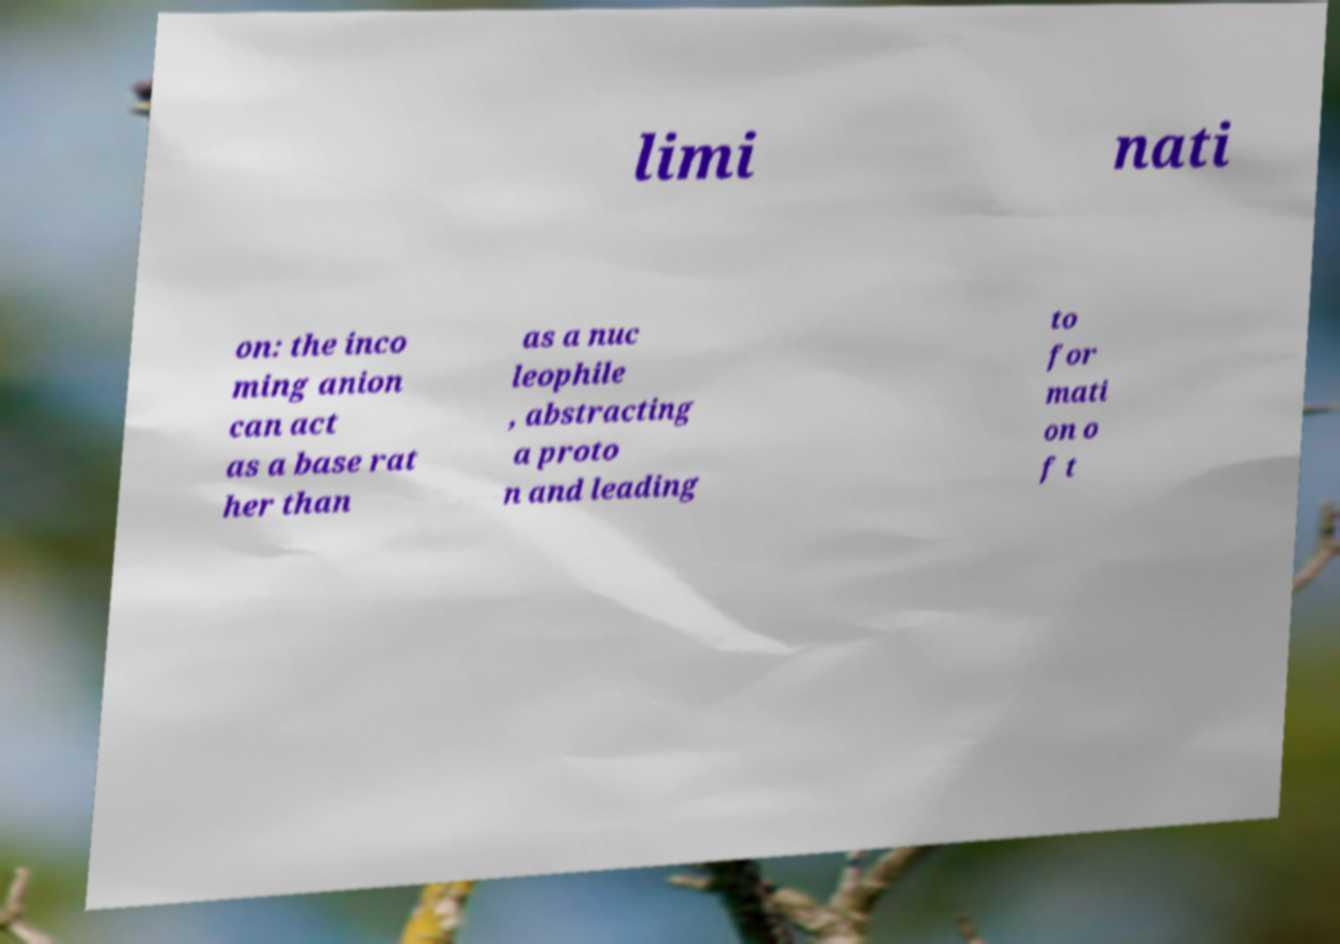What messages or text are displayed in this image? I need them in a readable, typed format. limi nati on: the inco ming anion can act as a base rat her than as a nuc leophile , abstracting a proto n and leading to for mati on o f t 